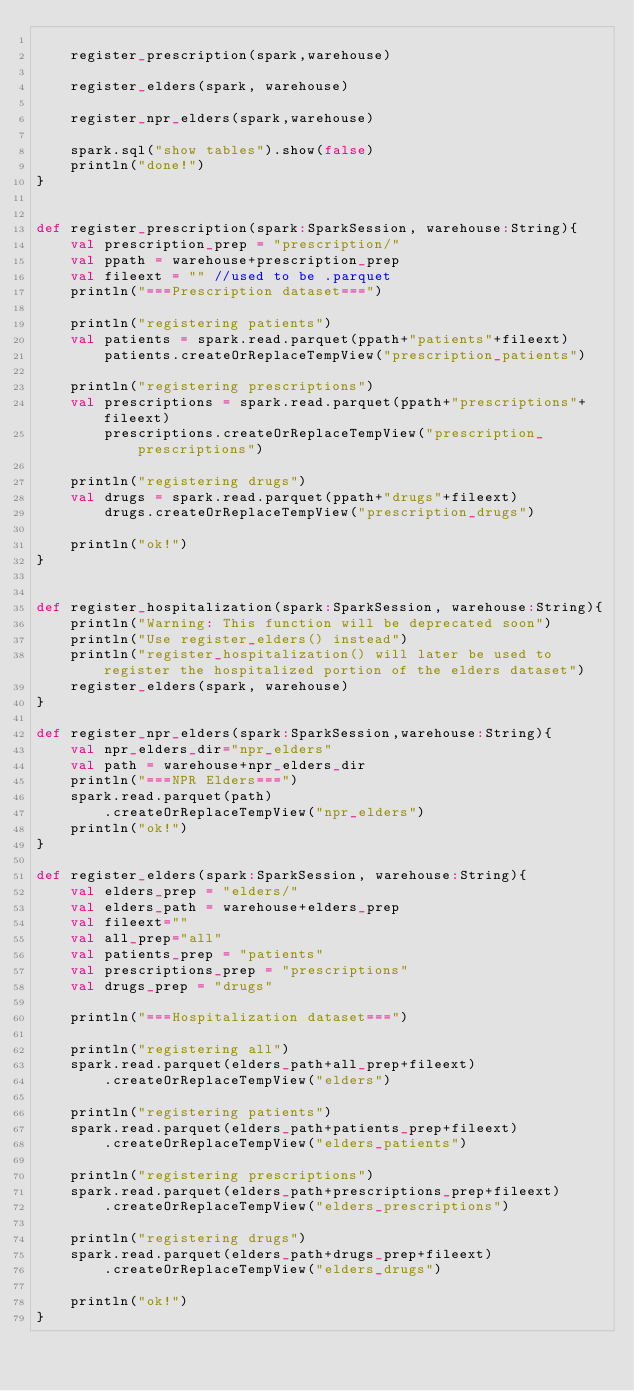<code> <loc_0><loc_0><loc_500><loc_500><_Scala_>    
    register_prescription(spark,warehouse)
    
    register_elders(spark, warehouse)
    
    register_npr_elders(spark,warehouse)
    
    spark.sql("show tables").show(false)
    println("done!")
}


def register_prescription(spark:SparkSession, warehouse:String){
    val prescription_prep = "prescription/"
    val ppath = warehouse+prescription_prep
    val fileext = "" //used to be .parquet
    println("===Prescription dataset===")
    
    println("registering patients")
    val patients = spark.read.parquet(ppath+"patients"+fileext)
        patients.createOrReplaceTempView("prescription_patients")
    
    println("registering prescriptions")
    val prescriptions = spark.read.parquet(ppath+"prescriptions"+fileext)
        prescriptions.createOrReplaceTempView("prescription_prescriptions")
    
    println("registering drugs")
    val drugs = spark.read.parquet(ppath+"drugs"+fileext)
        drugs.createOrReplaceTempView("prescription_drugs")
    
    println("ok!")
}


def register_hospitalization(spark:SparkSession, warehouse:String){
    println("Warning: This function will be deprecated soon")
    println("Use register_elders() instead")
    println("register_hospitalization() will later be used to register the hospitalized portion of the elders dataset")
    register_elders(spark, warehouse)
}

def register_npr_elders(spark:SparkSession,warehouse:String){
    val npr_elders_dir="npr_elders"
    val path = warehouse+npr_elders_dir
    println("===NPR Elders===")
    spark.read.parquet(path)
        .createOrReplaceTempView("npr_elders")
    println("ok!")
}

def register_elders(spark:SparkSession, warehouse:String){
    val elders_prep = "elders/"
    val elders_path = warehouse+elders_prep
    val fileext=""
    val all_prep="all"
    val patients_prep = "patients"
    val prescriptions_prep = "prescriptions"
    val drugs_prep = "drugs"
    
    println("===Hospitalization dataset===")
    
    println("registering all")
    spark.read.parquet(elders_path+all_prep+fileext)
        .createOrReplaceTempView("elders")
    
    println("registering patients")
    spark.read.parquet(elders_path+patients_prep+fileext)
        .createOrReplaceTempView("elders_patients")
    
    println("registering prescriptions")
    spark.read.parquet(elders_path+prescriptions_prep+fileext)
        .createOrReplaceTempView("elders_prescriptions")
    
    println("registering drugs")
    spark.read.parquet(elders_path+drugs_prep+fileext)
        .createOrReplaceTempView("elders_drugs")
    
    println("ok!")
}</code> 